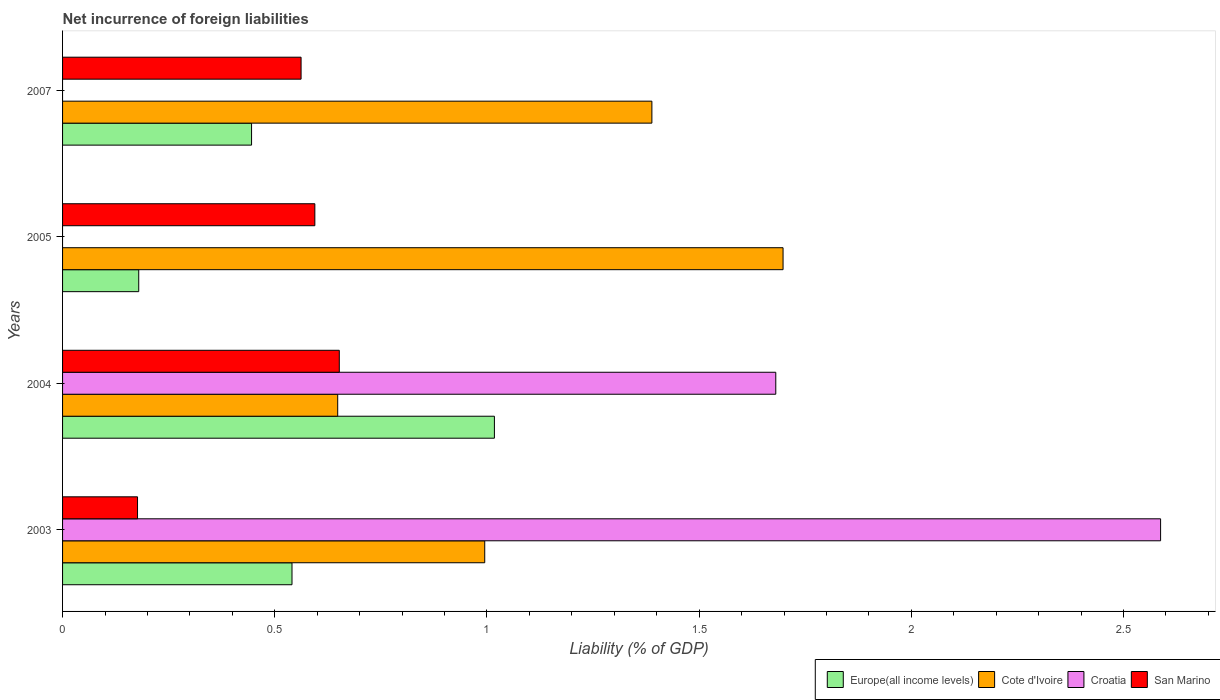How many different coloured bars are there?
Your response must be concise. 4. What is the net incurrence of foreign liabilities in Europe(all income levels) in 2007?
Your answer should be very brief. 0.45. Across all years, what is the maximum net incurrence of foreign liabilities in Europe(all income levels)?
Your answer should be compact. 1.02. Across all years, what is the minimum net incurrence of foreign liabilities in Europe(all income levels)?
Your answer should be very brief. 0.18. In which year was the net incurrence of foreign liabilities in San Marino maximum?
Your response must be concise. 2004. What is the total net incurrence of foreign liabilities in Croatia in the graph?
Provide a short and direct response. 4.27. What is the difference between the net incurrence of foreign liabilities in Cote d'Ivoire in 2003 and that in 2005?
Your answer should be very brief. -0.7. What is the difference between the net incurrence of foreign liabilities in Europe(all income levels) in 2004 and the net incurrence of foreign liabilities in Croatia in 2005?
Ensure brevity in your answer.  1.02. What is the average net incurrence of foreign liabilities in Croatia per year?
Offer a terse response. 1.07. In the year 2004, what is the difference between the net incurrence of foreign liabilities in Europe(all income levels) and net incurrence of foreign liabilities in Croatia?
Keep it short and to the point. -0.66. What is the ratio of the net incurrence of foreign liabilities in Europe(all income levels) in 2005 to that in 2007?
Your response must be concise. 0.4. Is the net incurrence of foreign liabilities in San Marino in 2004 less than that in 2007?
Keep it short and to the point. No. Is the difference between the net incurrence of foreign liabilities in Europe(all income levels) in 2003 and 2004 greater than the difference between the net incurrence of foreign liabilities in Croatia in 2003 and 2004?
Ensure brevity in your answer.  No. What is the difference between the highest and the second highest net incurrence of foreign liabilities in Cote d'Ivoire?
Your answer should be very brief. 0.31. What is the difference between the highest and the lowest net incurrence of foreign liabilities in San Marino?
Provide a succinct answer. 0.48. Is the sum of the net incurrence of foreign liabilities in San Marino in 2005 and 2007 greater than the maximum net incurrence of foreign liabilities in Croatia across all years?
Provide a succinct answer. No. Is it the case that in every year, the sum of the net incurrence of foreign liabilities in Cote d'Ivoire and net incurrence of foreign liabilities in San Marino is greater than the sum of net incurrence of foreign liabilities in Europe(all income levels) and net incurrence of foreign liabilities in Croatia?
Ensure brevity in your answer.  No. How many bars are there?
Make the answer very short. 14. Are all the bars in the graph horizontal?
Provide a succinct answer. Yes. How many years are there in the graph?
Your response must be concise. 4. What is the difference between two consecutive major ticks on the X-axis?
Provide a succinct answer. 0.5. Are the values on the major ticks of X-axis written in scientific E-notation?
Make the answer very short. No. Does the graph contain any zero values?
Offer a terse response. Yes. Does the graph contain grids?
Give a very brief answer. No. Where does the legend appear in the graph?
Your response must be concise. Bottom right. What is the title of the graph?
Make the answer very short. Net incurrence of foreign liabilities. What is the label or title of the X-axis?
Your response must be concise. Liability (% of GDP). What is the Liability (% of GDP) in Europe(all income levels) in 2003?
Your answer should be very brief. 0.54. What is the Liability (% of GDP) of Cote d'Ivoire in 2003?
Offer a terse response. 0.99. What is the Liability (% of GDP) of Croatia in 2003?
Ensure brevity in your answer.  2.59. What is the Liability (% of GDP) of San Marino in 2003?
Ensure brevity in your answer.  0.18. What is the Liability (% of GDP) of Europe(all income levels) in 2004?
Provide a succinct answer. 1.02. What is the Liability (% of GDP) of Cote d'Ivoire in 2004?
Ensure brevity in your answer.  0.65. What is the Liability (% of GDP) of Croatia in 2004?
Keep it short and to the point. 1.68. What is the Liability (% of GDP) in San Marino in 2004?
Provide a short and direct response. 0.65. What is the Liability (% of GDP) in Europe(all income levels) in 2005?
Ensure brevity in your answer.  0.18. What is the Liability (% of GDP) in Cote d'Ivoire in 2005?
Give a very brief answer. 1.7. What is the Liability (% of GDP) in San Marino in 2005?
Provide a succinct answer. 0.59. What is the Liability (% of GDP) of Europe(all income levels) in 2007?
Offer a very short reply. 0.45. What is the Liability (% of GDP) in Cote d'Ivoire in 2007?
Make the answer very short. 1.39. What is the Liability (% of GDP) in Croatia in 2007?
Your answer should be very brief. 0. What is the Liability (% of GDP) of San Marino in 2007?
Your answer should be very brief. 0.56. Across all years, what is the maximum Liability (% of GDP) of Europe(all income levels)?
Provide a succinct answer. 1.02. Across all years, what is the maximum Liability (% of GDP) in Cote d'Ivoire?
Give a very brief answer. 1.7. Across all years, what is the maximum Liability (% of GDP) of Croatia?
Ensure brevity in your answer.  2.59. Across all years, what is the maximum Liability (% of GDP) in San Marino?
Ensure brevity in your answer.  0.65. Across all years, what is the minimum Liability (% of GDP) in Europe(all income levels)?
Your response must be concise. 0.18. Across all years, what is the minimum Liability (% of GDP) of Cote d'Ivoire?
Provide a short and direct response. 0.65. Across all years, what is the minimum Liability (% of GDP) in Croatia?
Make the answer very short. 0. Across all years, what is the minimum Liability (% of GDP) in San Marino?
Make the answer very short. 0.18. What is the total Liability (% of GDP) of Europe(all income levels) in the graph?
Your response must be concise. 2.18. What is the total Liability (% of GDP) of Cote d'Ivoire in the graph?
Your answer should be very brief. 4.73. What is the total Liability (% of GDP) in Croatia in the graph?
Offer a very short reply. 4.27. What is the total Liability (% of GDP) of San Marino in the graph?
Your response must be concise. 1.99. What is the difference between the Liability (% of GDP) of Europe(all income levels) in 2003 and that in 2004?
Offer a very short reply. -0.48. What is the difference between the Liability (% of GDP) in Cote d'Ivoire in 2003 and that in 2004?
Make the answer very short. 0.35. What is the difference between the Liability (% of GDP) of Croatia in 2003 and that in 2004?
Give a very brief answer. 0.91. What is the difference between the Liability (% of GDP) in San Marino in 2003 and that in 2004?
Your answer should be compact. -0.48. What is the difference between the Liability (% of GDP) of Europe(all income levels) in 2003 and that in 2005?
Your response must be concise. 0.36. What is the difference between the Liability (% of GDP) of Cote d'Ivoire in 2003 and that in 2005?
Your answer should be very brief. -0.7. What is the difference between the Liability (% of GDP) of San Marino in 2003 and that in 2005?
Provide a succinct answer. -0.42. What is the difference between the Liability (% of GDP) of Europe(all income levels) in 2003 and that in 2007?
Your answer should be very brief. 0.1. What is the difference between the Liability (% of GDP) in Cote d'Ivoire in 2003 and that in 2007?
Your response must be concise. -0.39. What is the difference between the Liability (% of GDP) in San Marino in 2003 and that in 2007?
Your answer should be very brief. -0.39. What is the difference between the Liability (% of GDP) in Europe(all income levels) in 2004 and that in 2005?
Offer a very short reply. 0.84. What is the difference between the Liability (% of GDP) in Cote d'Ivoire in 2004 and that in 2005?
Your answer should be very brief. -1.05. What is the difference between the Liability (% of GDP) in San Marino in 2004 and that in 2005?
Make the answer very short. 0.06. What is the difference between the Liability (% of GDP) of Europe(all income levels) in 2004 and that in 2007?
Keep it short and to the point. 0.57. What is the difference between the Liability (% of GDP) in Cote d'Ivoire in 2004 and that in 2007?
Keep it short and to the point. -0.74. What is the difference between the Liability (% of GDP) of San Marino in 2004 and that in 2007?
Offer a terse response. 0.09. What is the difference between the Liability (% of GDP) of Europe(all income levels) in 2005 and that in 2007?
Keep it short and to the point. -0.27. What is the difference between the Liability (% of GDP) in Cote d'Ivoire in 2005 and that in 2007?
Your answer should be very brief. 0.31. What is the difference between the Liability (% of GDP) of San Marino in 2005 and that in 2007?
Offer a very short reply. 0.03. What is the difference between the Liability (% of GDP) of Europe(all income levels) in 2003 and the Liability (% of GDP) of Cote d'Ivoire in 2004?
Keep it short and to the point. -0.11. What is the difference between the Liability (% of GDP) in Europe(all income levels) in 2003 and the Liability (% of GDP) in Croatia in 2004?
Your answer should be compact. -1.14. What is the difference between the Liability (% of GDP) in Europe(all income levels) in 2003 and the Liability (% of GDP) in San Marino in 2004?
Ensure brevity in your answer.  -0.11. What is the difference between the Liability (% of GDP) in Cote d'Ivoire in 2003 and the Liability (% of GDP) in Croatia in 2004?
Offer a terse response. -0.69. What is the difference between the Liability (% of GDP) in Cote d'Ivoire in 2003 and the Liability (% of GDP) in San Marino in 2004?
Ensure brevity in your answer.  0.34. What is the difference between the Liability (% of GDP) of Croatia in 2003 and the Liability (% of GDP) of San Marino in 2004?
Your response must be concise. 1.94. What is the difference between the Liability (% of GDP) of Europe(all income levels) in 2003 and the Liability (% of GDP) of Cote d'Ivoire in 2005?
Offer a very short reply. -1.16. What is the difference between the Liability (% of GDP) in Europe(all income levels) in 2003 and the Liability (% of GDP) in San Marino in 2005?
Ensure brevity in your answer.  -0.05. What is the difference between the Liability (% of GDP) in Cote d'Ivoire in 2003 and the Liability (% of GDP) in San Marino in 2005?
Offer a very short reply. 0.4. What is the difference between the Liability (% of GDP) in Croatia in 2003 and the Liability (% of GDP) in San Marino in 2005?
Make the answer very short. 1.99. What is the difference between the Liability (% of GDP) of Europe(all income levels) in 2003 and the Liability (% of GDP) of Cote d'Ivoire in 2007?
Your answer should be compact. -0.85. What is the difference between the Liability (% of GDP) in Europe(all income levels) in 2003 and the Liability (% of GDP) in San Marino in 2007?
Keep it short and to the point. -0.02. What is the difference between the Liability (% of GDP) of Cote d'Ivoire in 2003 and the Liability (% of GDP) of San Marino in 2007?
Offer a very short reply. 0.43. What is the difference between the Liability (% of GDP) in Croatia in 2003 and the Liability (% of GDP) in San Marino in 2007?
Your answer should be very brief. 2.03. What is the difference between the Liability (% of GDP) of Europe(all income levels) in 2004 and the Liability (% of GDP) of Cote d'Ivoire in 2005?
Ensure brevity in your answer.  -0.68. What is the difference between the Liability (% of GDP) in Europe(all income levels) in 2004 and the Liability (% of GDP) in San Marino in 2005?
Provide a succinct answer. 0.42. What is the difference between the Liability (% of GDP) in Cote d'Ivoire in 2004 and the Liability (% of GDP) in San Marino in 2005?
Your answer should be compact. 0.05. What is the difference between the Liability (% of GDP) in Croatia in 2004 and the Liability (% of GDP) in San Marino in 2005?
Provide a succinct answer. 1.09. What is the difference between the Liability (% of GDP) of Europe(all income levels) in 2004 and the Liability (% of GDP) of Cote d'Ivoire in 2007?
Ensure brevity in your answer.  -0.37. What is the difference between the Liability (% of GDP) of Europe(all income levels) in 2004 and the Liability (% of GDP) of San Marino in 2007?
Your answer should be very brief. 0.46. What is the difference between the Liability (% of GDP) of Cote d'Ivoire in 2004 and the Liability (% of GDP) of San Marino in 2007?
Provide a short and direct response. 0.09. What is the difference between the Liability (% of GDP) in Croatia in 2004 and the Liability (% of GDP) in San Marino in 2007?
Your answer should be very brief. 1.12. What is the difference between the Liability (% of GDP) in Europe(all income levels) in 2005 and the Liability (% of GDP) in Cote d'Ivoire in 2007?
Your answer should be compact. -1.21. What is the difference between the Liability (% of GDP) in Europe(all income levels) in 2005 and the Liability (% of GDP) in San Marino in 2007?
Offer a very short reply. -0.38. What is the difference between the Liability (% of GDP) in Cote d'Ivoire in 2005 and the Liability (% of GDP) in San Marino in 2007?
Give a very brief answer. 1.14. What is the average Liability (% of GDP) of Europe(all income levels) per year?
Ensure brevity in your answer.  0.55. What is the average Liability (% of GDP) in Cote d'Ivoire per year?
Provide a succinct answer. 1.18. What is the average Liability (% of GDP) of Croatia per year?
Provide a succinct answer. 1.07. What is the average Liability (% of GDP) in San Marino per year?
Provide a short and direct response. 0.5. In the year 2003, what is the difference between the Liability (% of GDP) in Europe(all income levels) and Liability (% of GDP) in Cote d'Ivoire?
Provide a short and direct response. -0.45. In the year 2003, what is the difference between the Liability (% of GDP) of Europe(all income levels) and Liability (% of GDP) of Croatia?
Provide a succinct answer. -2.05. In the year 2003, what is the difference between the Liability (% of GDP) in Europe(all income levels) and Liability (% of GDP) in San Marino?
Offer a very short reply. 0.36. In the year 2003, what is the difference between the Liability (% of GDP) of Cote d'Ivoire and Liability (% of GDP) of Croatia?
Your answer should be compact. -1.59. In the year 2003, what is the difference between the Liability (% of GDP) of Cote d'Ivoire and Liability (% of GDP) of San Marino?
Give a very brief answer. 0.82. In the year 2003, what is the difference between the Liability (% of GDP) in Croatia and Liability (% of GDP) in San Marino?
Offer a terse response. 2.41. In the year 2004, what is the difference between the Liability (% of GDP) in Europe(all income levels) and Liability (% of GDP) in Cote d'Ivoire?
Provide a short and direct response. 0.37. In the year 2004, what is the difference between the Liability (% of GDP) in Europe(all income levels) and Liability (% of GDP) in Croatia?
Offer a terse response. -0.66. In the year 2004, what is the difference between the Liability (% of GDP) in Europe(all income levels) and Liability (% of GDP) in San Marino?
Offer a very short reply. 0.37. In the year 2004, what is the difference between the Liability (% of GDP) of Cote d'Ivoire and Liability (% of GDP) of Croatia?
Provide a succinct answer. -1.03. In the year 2004, what is the difference between the Liability (% of GDP) in Cote d'Ivoire and Liability (% of GDP) in San Marino?
Provide a succinct answer. -0. In the year 2004, what is the difference between the Liability (% of GDP) of Croatia and Liability (% of GDP) of San Marino?
Your answer should be very brief. 1.03. In the year 2005, what is the difference between the Liability (% of GDP) in Europe(all income levels) and Liability (% of GDP) in Cote d'Ivoire?
Offer a very short reply. -1.52. In the year 2005, what is the difference between the Liability (% of GDP) of Europe(all income levels) and Liability (% of GDP) of San Marino?
Provide a succinct answer. -0.41. In the year 2005, what is the difference between the Liability (% of GDP) in Cote d'Ivoire and Liability (% of GDP) in San Marino?
Offer a terse response. 1.1. In the year 2007, what is the difference between the Liability (% of GDP) of Europe(all income levels) and Liability (% of GDP) of Cote d'Ivoire?
Your answer should be compact. -0.94. In the year 2007, what is the difference between the Liability (% of GDP) in Europe(all income levels) and Liability (% of GDP) in San Marino?
Offer a terse response. -0.12. In the year 2007, what is the difference between the Liability (% of GDP) in Cote d'Ivoire and Liability (% of GDP) in San Marino?
Offer a very short reply. 0.83. What is the ratio of the Liability (% of GDP) of Europe(all income levels) in 2003 to that in 2004?
Ensure brevity in your answer.  0.53. What is the ratio of the Liability (% of GDP) in Cote d'Ivoire in 2003 to that in 2004?
Your response must be concise. 1.53. What is the ratio of the Liability (% of GDP) of Croatia in 2003 to that in 2004?
Offer a very short reply. 1.54. What is the ratio of the Liability (% of GDP) of San Marino in 2003 to that in 2004?
Keep it short and to the point. 0.27. What is the ratio of the Liability (% of GDP) of Europe(all income levels) in 2003 to that in 2005?
Ensure brevity in your answer.  3.01. What is the ratio of the Liability (% of GDP) in Cote d'Ivoire in 2003 to that in 2005?
Give a very brief answer. 0.59. What is the ratio of the Liability (% of GDP) in San Marino in 2003 to that in 2005?
Your answer should be compact. 0.3. What is the ratio of the Liability (% of GDP) in Europe(all income levels) in 2003 to that in 2007?
Your answer should be very brief. 1.21. What is the ratio of the Liability (% of GDP) of Cote d'Ivoire in 2003 to that in 2007?
Offer a very short reply. 0.72. What is the ratio of the Liability (% of GDP) of San Marino in 2003 to that in 2007?
Your answer should be very brief. 0.31. What is the ratio of the Liability (% of GDP) of Europe(all income levels) in 2004 to that in 2005?
Offer a terse response. 5.67. What is the ratio of the Liability (% of GDP) in Cote d'Ivoire in 2004 to that in 2005?
Make the answer very short. 0.38. What is the ratio of the Liability (% of GDP) in San Marino in 2004 to that in 2005?
Give a very brief answer. 1.1. What is the ratio of the Liability (% of GDP) in Europe(all income levels) in 2004 to that in 2007?
Keep it short and to the point. 2.28. What is the ratio of the Liability (% of GDP) of Cote d'Ivoire in 2004 to that in 2007?
Make the answer very short. 0.47. What is the ratio of the Liability (% of GDP) in San Marino in 2004 to that in 2007?
Give a very brief answer. 1.16. What is the ratio of the Liability (% of GDP) of Europe(all income levels) in 2005 to that in 2007?
Your response must be concise. 0.4. What is the ratio of the Liability (% of GDP) in Cote d'Ivoire in 2005 to that in 2007?
Your answer should be compact. 1.22. What is the ratio of the Liability (% of GDP) of San Marino in 2005 to that in 2007?
Provide a succinct answer. 1.06. What is the difference between the highest and the second highest Liability (% of GDP) of Europe(all income levels)?
Give a very brief answer. 0.48. What is the difference between the highest and the second highest Liability (% of GDP) in Cote d'Ivoire?
Ensure brevity in your answer.  0.31. What is the difference between the highest and the second highest Liability (% of GDP) in San Marino?
Ensure brevity in your answer.  0.06. What is the difference between the highest and the lowest Liability (% of GDP) of Europe(all income levels)?
Offer a very short reply. 0.84. What is the difference between the highest and the lowest Liability (% of GDP) of Cote d'Ivoire?
Provide a short and direct response. 1.05. What is the difference between the highest and the lowest Liability (% of GDP) of Croatia?
Your answer should be very brief. 2.59. What is the difference between the highest and the lowest Liability (% of GDP) in San Marino?
Your response must be concise. 0.48. 